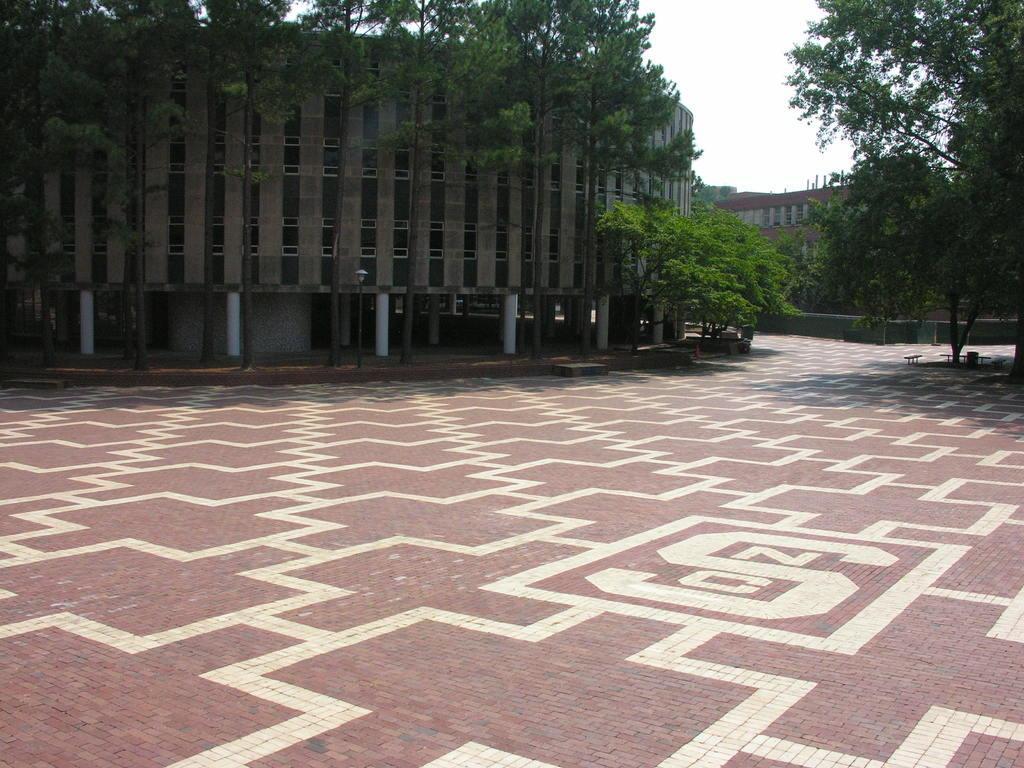Please provide a concise description of this image. In this picture I can see there is a white design on the floor and there are two buildings at left and right sides. There are few trees and the sky is clear. 